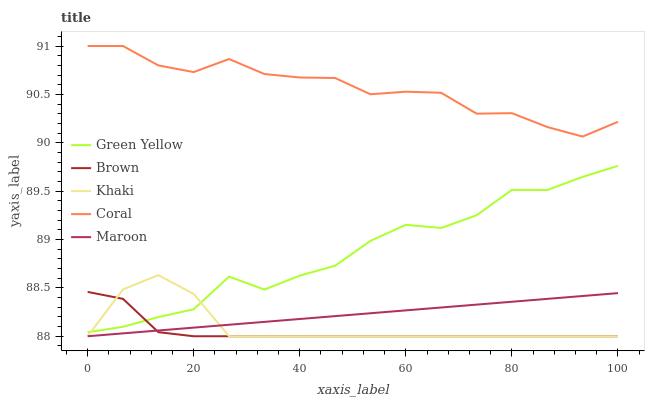Does Brown have the minimum area under the curve?
Answer yes or no. Yes. Does Coral have the maximum area under the curve?
Answer yes or no. Yes. Does Green Yellow have the minimum area under the curve?
Answer yes or no. No. Does Green Yellow have the maximum area under the curve?
Answer yes or no. No. Is Maroon the smoothest?
Answer yes or no. Yes. Is Green Yellow the roughest?
Answer yes or no. Yes. Is Coral the smoothest?
Answer yes or no. No. Is Coral the roughest?
Answer yes or no. No. Does Brown have the lowest value?
Answer yes or no. Yes. Does Green Yellow have the lowest value?
Answer yes or no. No. Does Coral have the highest value?
Answer yes or no. Yes. Does Green Yellow have the highest value?
Answer yes or no. No. Is Green Yellow less than Coral?
Answer yes or no. Yes. Is Coral greater than Khaki?
Answer yes or no. Yes. Does Brown intersect Maroon?
Answer yes or no. Yes. Is Brown less than Maroon?
Answer yes or no. No. Is Brown greater than Maroon?
Answer yes or no. No. Does Green Yellow intersect Coral?
Answer yes or no. No. 